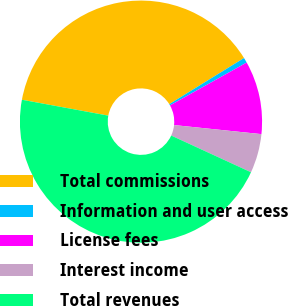Convert chart. <chart><loc_0><loc_0><loc_500><loc_500><pie_chart><fcel>Total commissions<fcel>Information and user access<fcel>License fees<fcel>Interest income<fcel>Total revenues<nl><fcel>38.3%<fcel>0.69%<fcel>9.76%<fcel>5.22%<fcel>46.03%<nl></chart> 